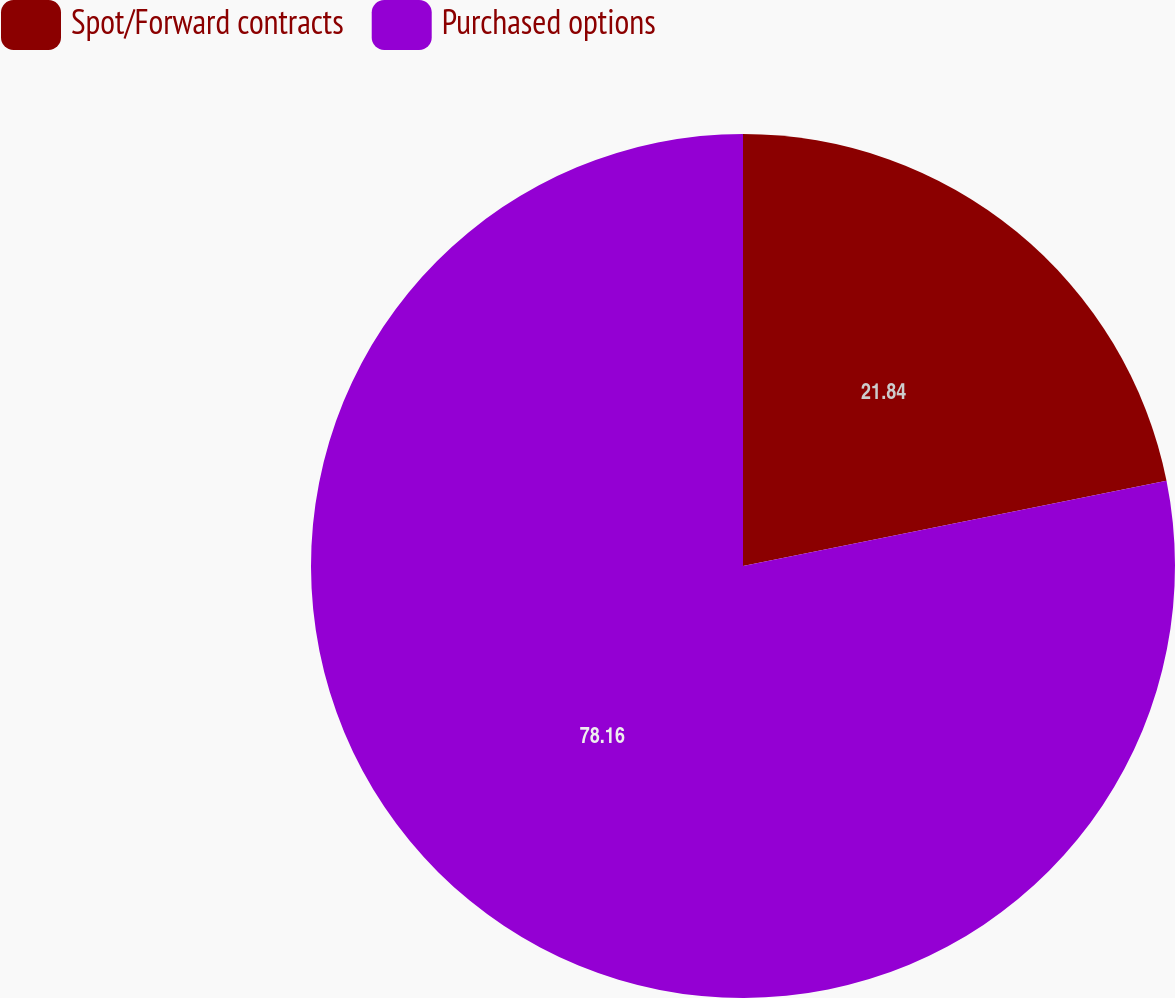<chart> <loc_0><loc_0><loc_500><loc_500><pie_chart><fcel>Spot/Forward contracts<fcel>Purchased options<nl><fcel>21.84%<fcel>78.16%<nl></chart> 